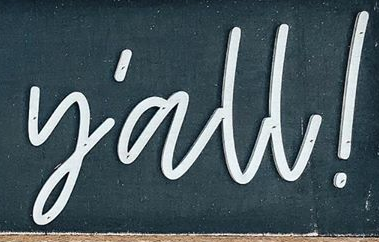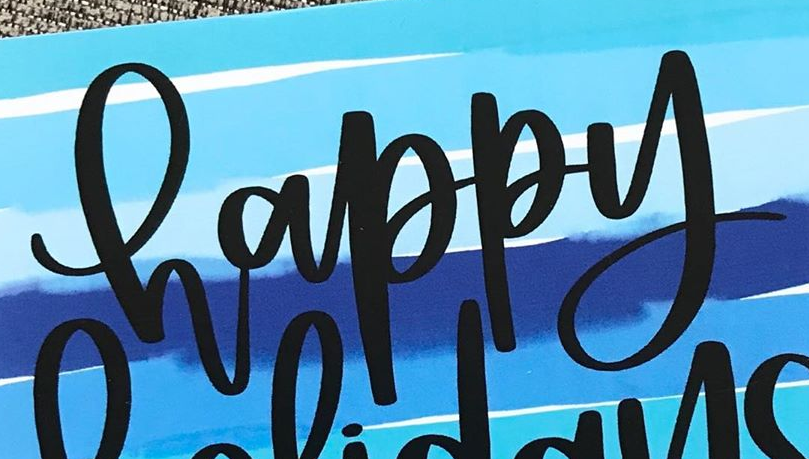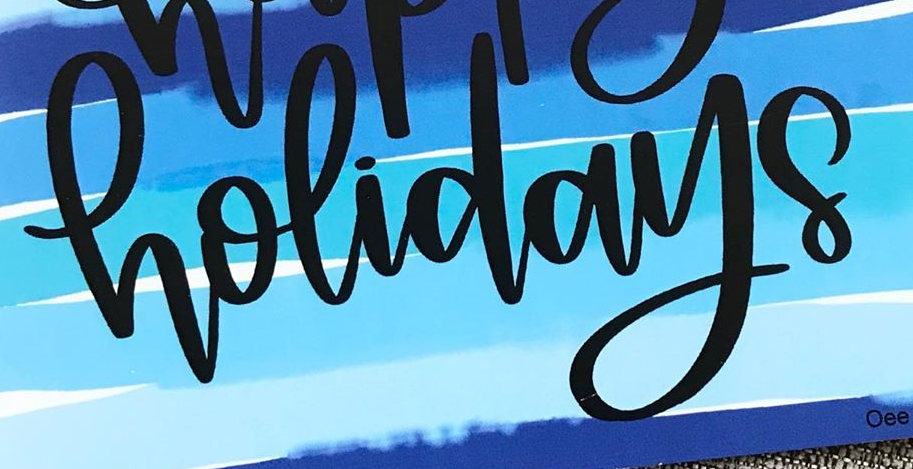What text appears in these images from left to right, separated by a semicolon? y'all!; happy; holidays 